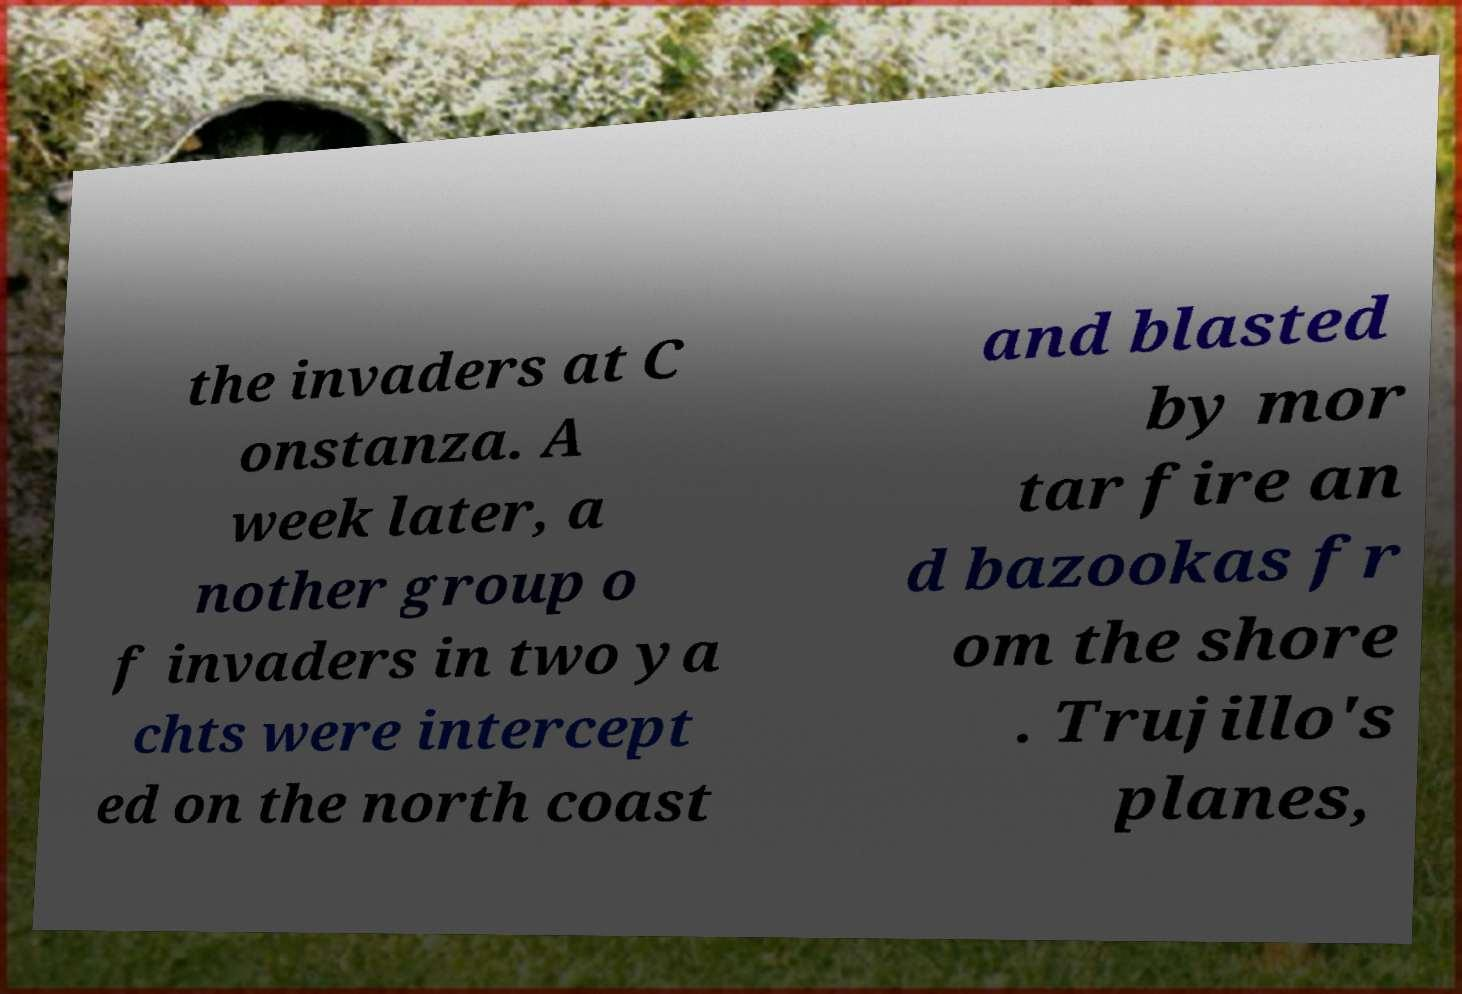What messages or text are displayed in this image? I need them in a readable, typed format. the invaders at C onstanza. A week later, a nother group o f invaders in two ya chts were intercept ed on the north coast and blasted by mor tar fire an d bazookas fr om the shore . Trujillo's planes, 